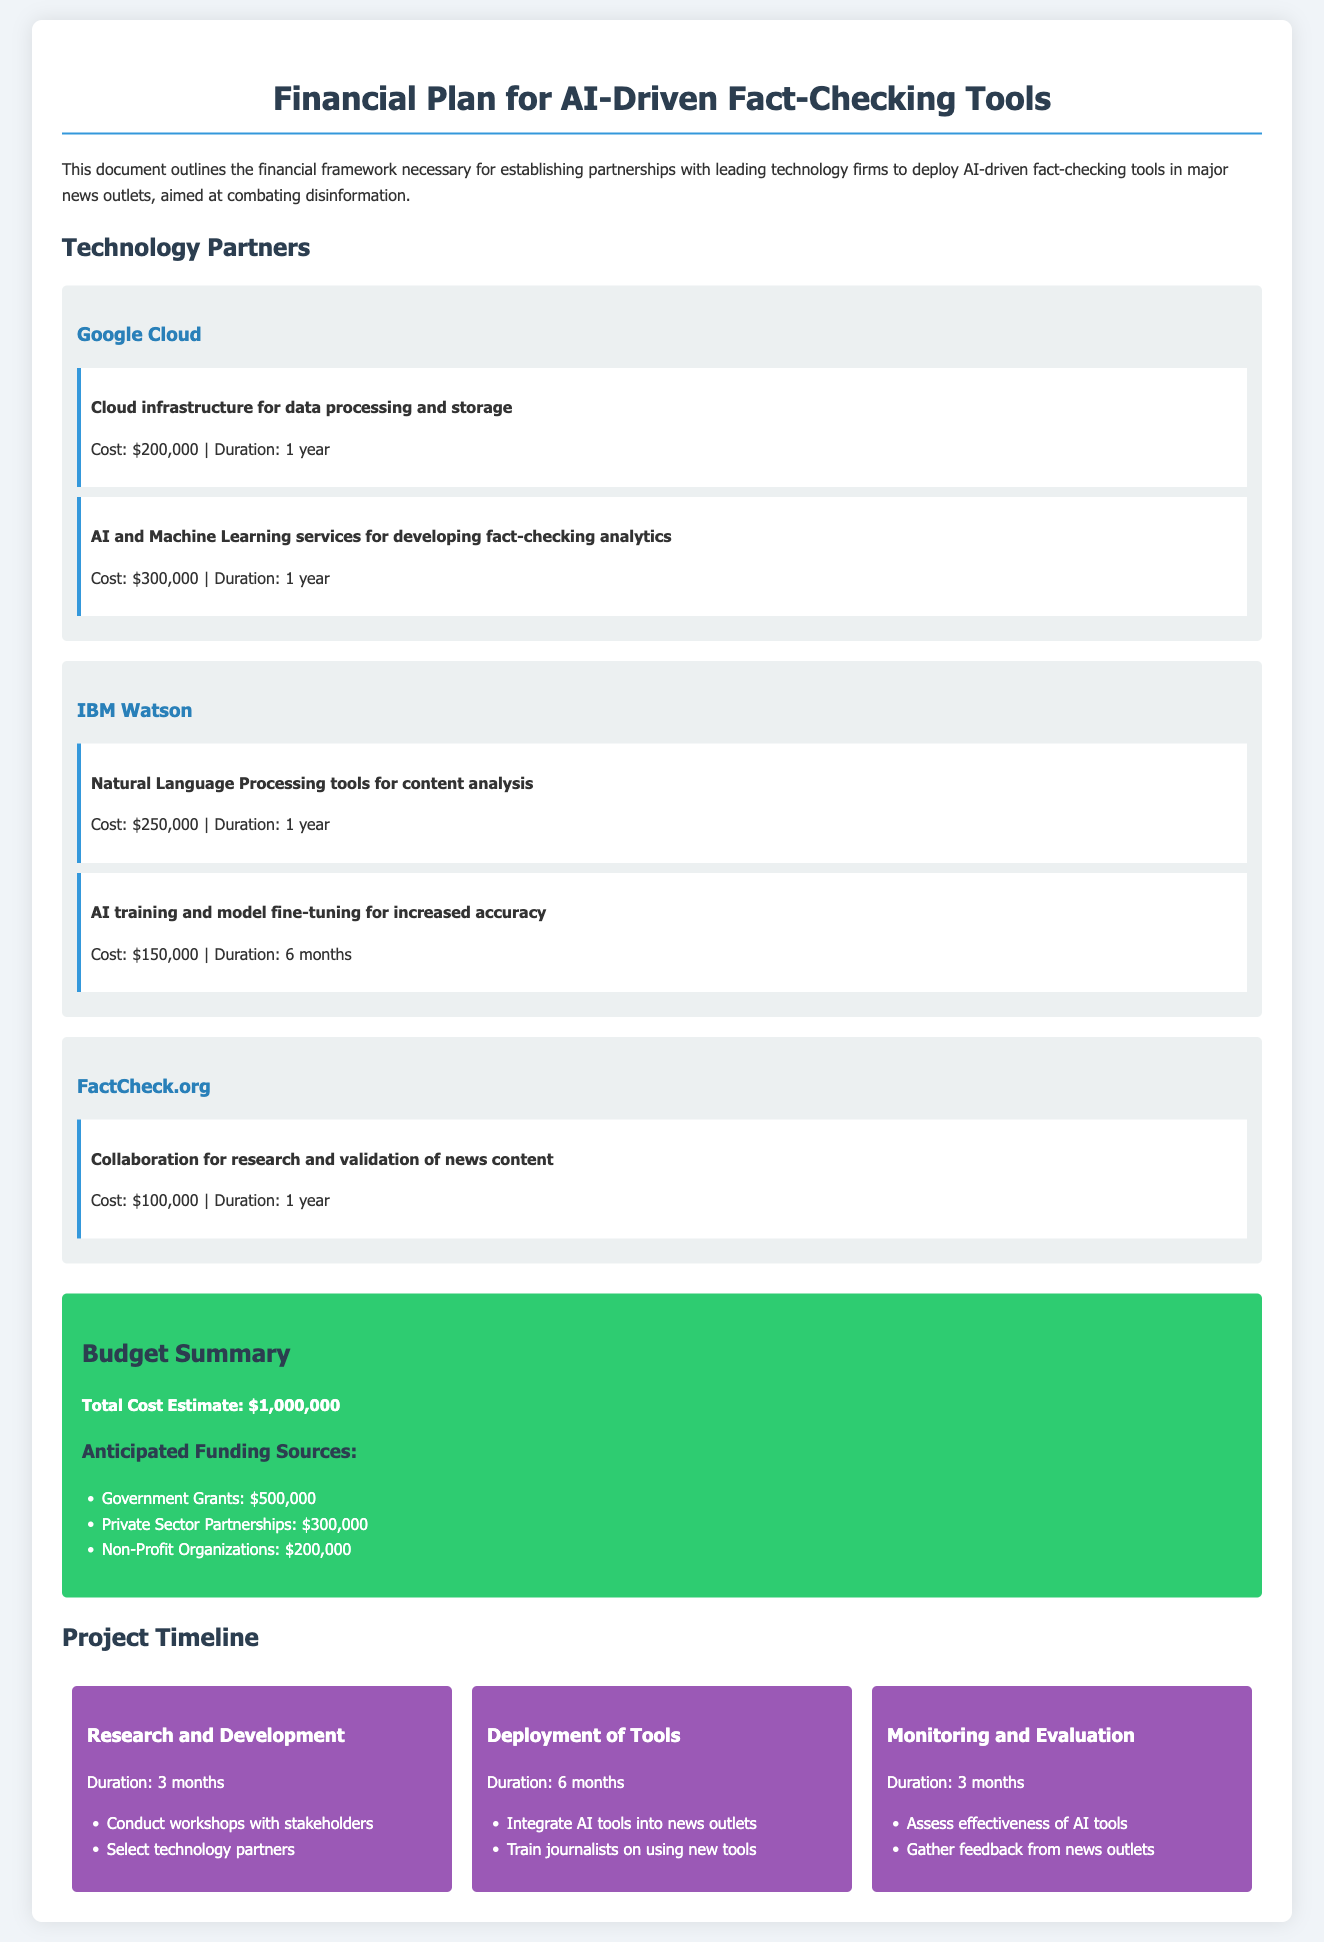what is the total cost estimate? The total cost estimate is stated at the end of the budget summary section of the document.
Answer: $1,000,000 how much funding is anticipated from government grants? The document lists anticipated funding sources, highlighting the amount from government grants.
Answer: $500,000 which technology partner provides natural language processing tools? The document mentions various technology partners and associated services, specifying the provider for natural language processing tools.
Answer: IBM Watson what is the duration of the deployment phase? The deployment phase duration is included in the project timeline section, detailing the length of time for this phase.
Answer: 6 months how much will FactCheck.org cost for collaboration? The cost for collaboration with FactCheck.org is outlined in the partner section of the document.
Answer: $100,000 what is the total budget from private sector partnerships? The anticipated funding sources are listed, showing the breakdown and total from private sector partnerships.
Answer: $300,000 what is the duration for the research and development phase? The document describes various phases of the project, including their respective durations.
Answer: 3 months which technology partner is responsible for AI training and model fine-tuning? The document includes a section for each technology partner and specifies those that provide AI training and model fine-tuning services.
Answer: IBM Watson 